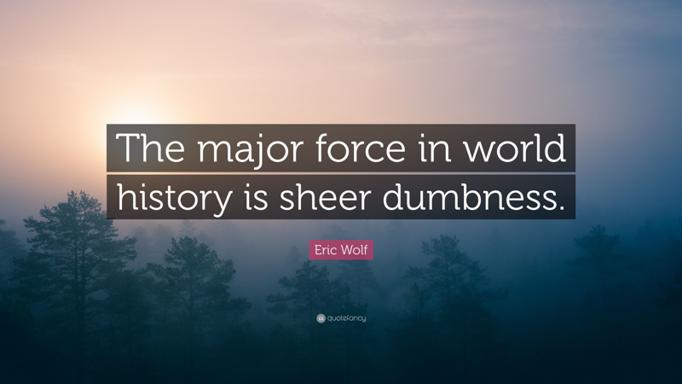What does the quote by Eric Wolf mean? The quote by Eric Wolf, 'The major force in world history is sheer dumbness', serves as a critical reflection on historical decision-making. Wolf suggests that many pivotal events are shaped more by lack of foresight and wisdom than strategic intention. This perspective encourages a deeper consideration of the intellectual and reflective capacities utilized in history-making, urging modern societies to cultivate more thoughtful and informed decision-making processes to avoid repeated mistakes. 